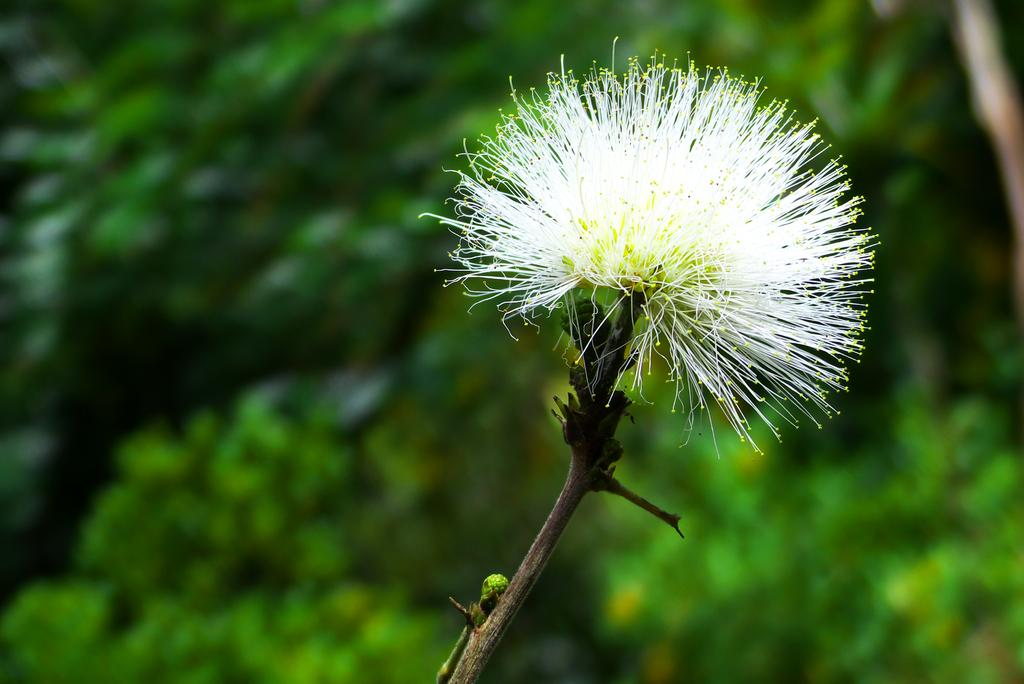What is the main subject of the image? There is a flower in the image. Can you describe the color of the flower? The flower is white and green in color. Is the flower part of a larger plant? Yes, the flower is attached to a plant. What colors are present in the background of the image? The background of the image is green and black in color. How would you describe the appearance of the background? The background appears blurry. What type of gold exchange is taking place in the image? There is no gold exchange or any reference to gold in the image; it features a flower and a blurry background. 